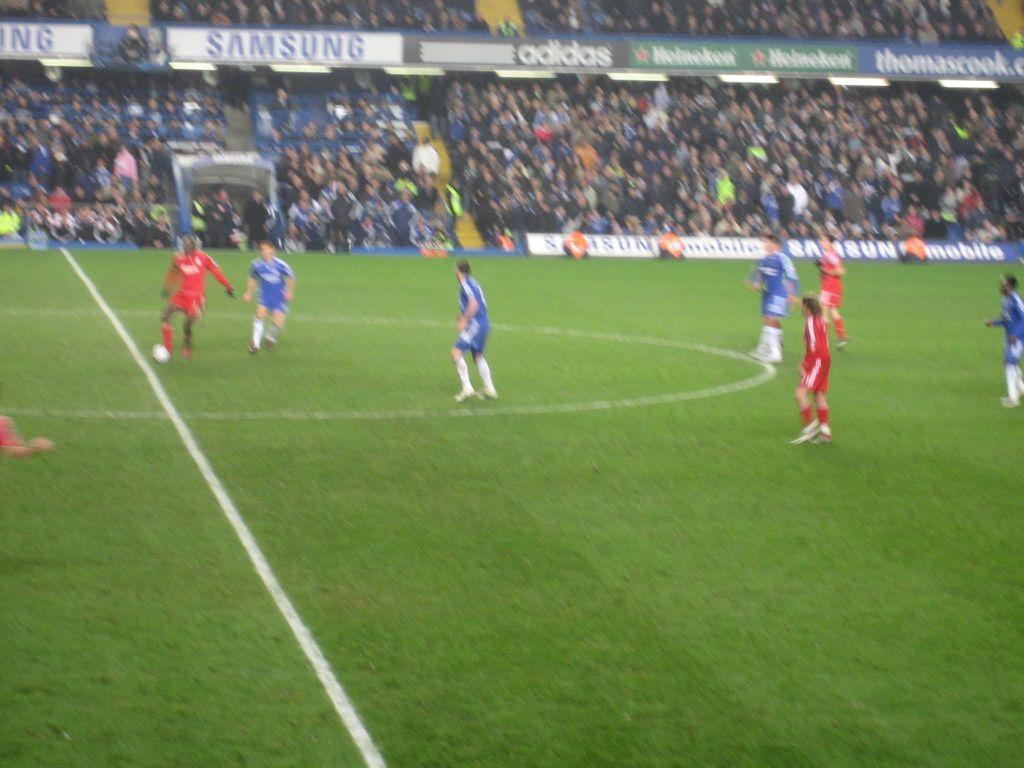<image>
Render a clear and concise summary of the photo. A soccer field with players wearing either blue or red jerseys and Samsung as a sponsor. 